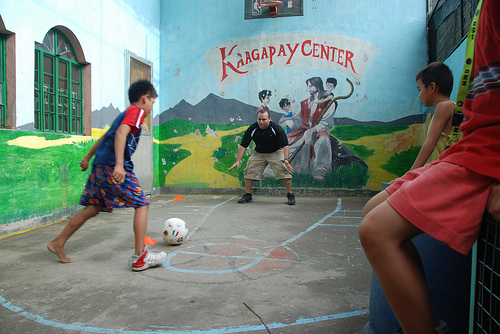<image>
Can you confirm if the boy is behind the ball? No. The boy is not behind the ball. From this viewpoint, the boy appears to be positioned elsewhere in the scene. Is there a ball in front of the man? Yes. The ball is positioned in front of the man, appearing closer to the camera viewpoint. 